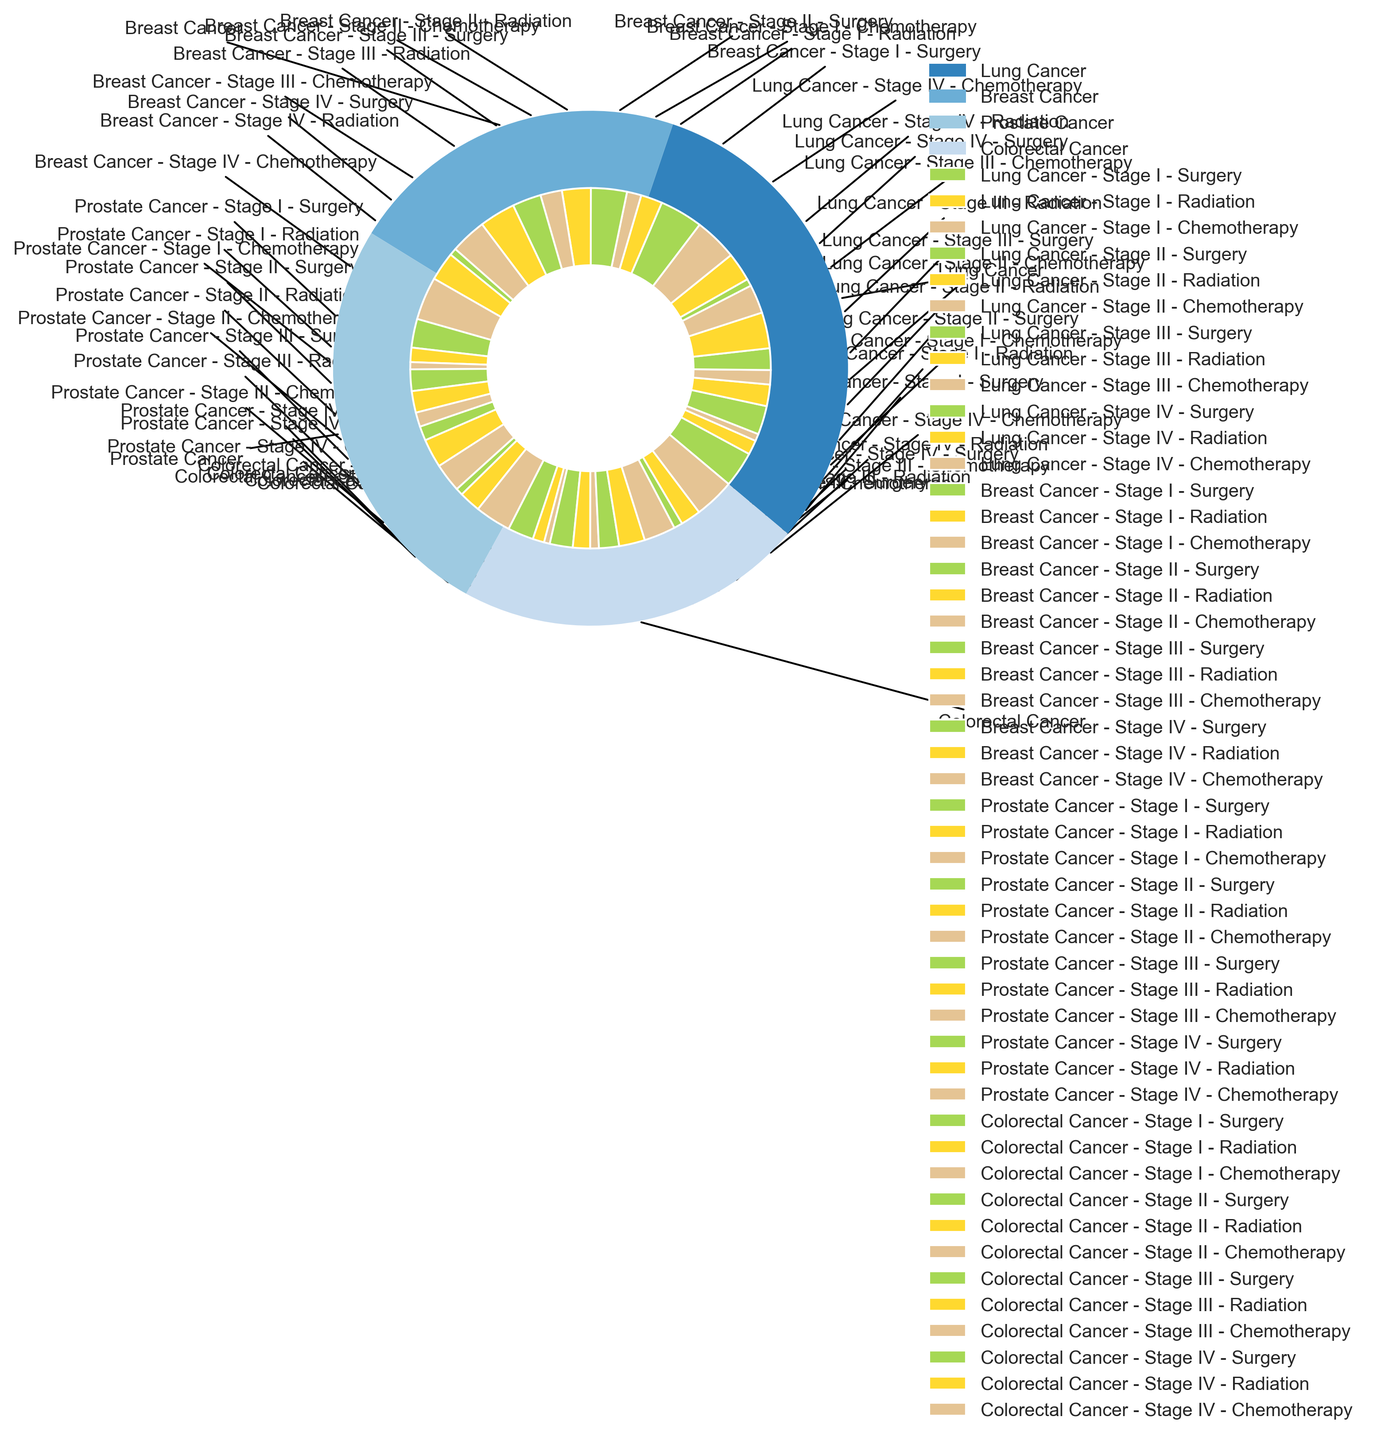Which cancer type has the highest overall incidence rate? To determine which cancer type has the highest overall incidence rate, look at the outermost part of the pie chart where each cancer type is proportionally represented. The section with the largest size indicates the highest overall incidence rate.
Answer: Breast Cancer Which stage has the highest incidence rate for Lung Cancer? For this, focus on the segment labeled "Lung Cancer" and examine the inner segments which represent each stage. Identify the stage segment with the largest size.
Answer: Stage III What is the total incidence rate of Colorectal Cancer for all stages combined? To calculate this, sum up the incidence rates for all stages of Colorectal Cancer:
18 (Stage I) + 16 (Stage II) + 14 (Stage III) + 6 (Stage IV) = 54. Therefore, the total incidence rate is 54.
Answer: 54 Which treatment modality is most common for Stage IV in Prostate Cancer? Navigate to the Prostate Cancer segment and find the Stage IV subsection. Compare the treatments (Surgery, Radiation, and Chemotherapy) and select the one with the largest section.
Answer: Chemotherapy Compare the incidence rate of Surgery in Stage II Breast Cancer and Stage II Lung Cancer. Which is higher? Look at the incisions for each, focusing on the Surgery sections in Stage II for both Breast Cancer and Lung Cancer. Compare their sizes. Breast Cancer - Stage II Surgery has an incidence rate of 25, Lung Cancer - Stage II Surgery has an incidence rate of 20.
Answer: Breast Cancer - Stage II What is the combined incidence rate of Radiation treatment for Stage I cancers across all types? Add up the incidence rates for Radiation treatment in Stage I across all cancer types: Lung Cancer (10) + Breast Cancer (15) + Prostate Cancer (10) + Colorectal Cancer (8) = 43.
Answer: 43 Which cancer type has the most balanced distribution among its stages? Look at each cancer type and check the distribution within each, finding the one where stage proportions look most equal.
Answer: Colorectal Cancer What percentage of the total incidence rate does Lung Cancer at Stage III account for? First find the total incidence rate by summing all values. Then calculate the percentage contribution of Stage III Lung Cancer ((15 + 25 + 20) / Total Incidence Rate) * 100%. Assume the total incidence rate is calculated as 422. This gives ((60 / 422) * 100%) = approximately 14.22%.
Answer: 14.22% For which cancer type does Chemotherapy have the lowest overall incidence rate? For each cancer type, sum the incidence rates for Chemotherapy across all stages. Then find the type with the smallest total sum. Here, you need to compare:
Lung Cancer (5+10+20+30),
Breast Cancer (10+15+25+30), 
Prostate Cancer (5+10+20+25), 
Colorectal Cancer (4+6+22+28). The lowest sum is for Prostate Cancer, which is 60.
Answer: Prostate Cancer 